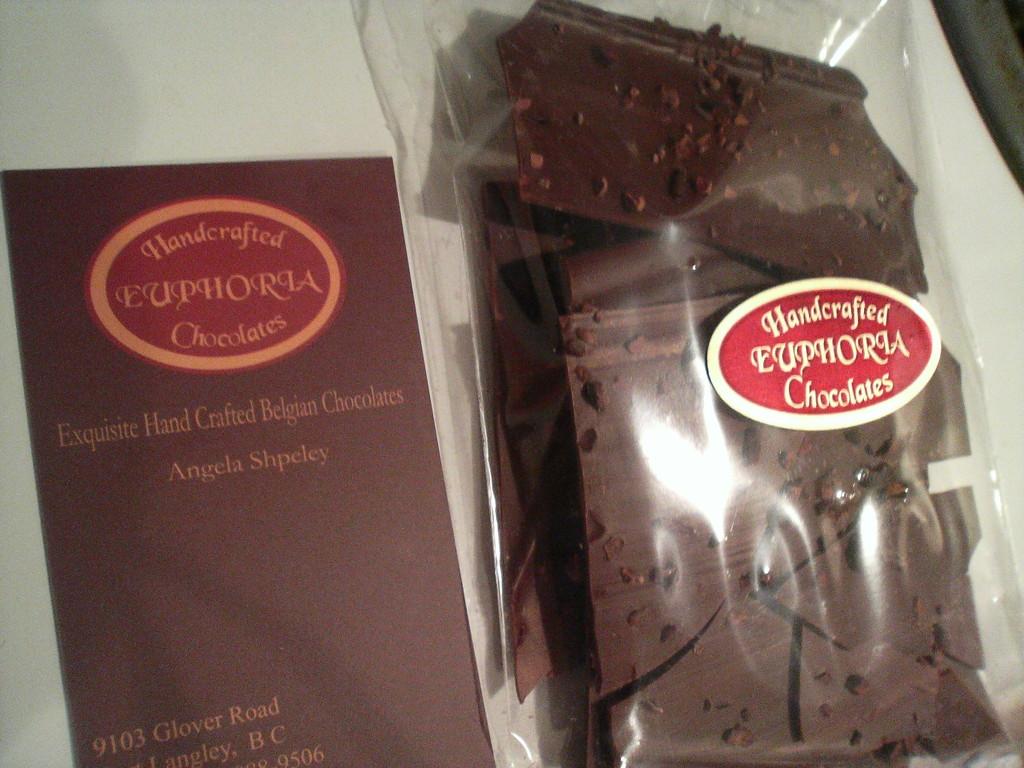What kind of candy is this?
Make the answer very short. Chocolates. Where is this chocolate made?
Provide a succinct answer. Belgium. 